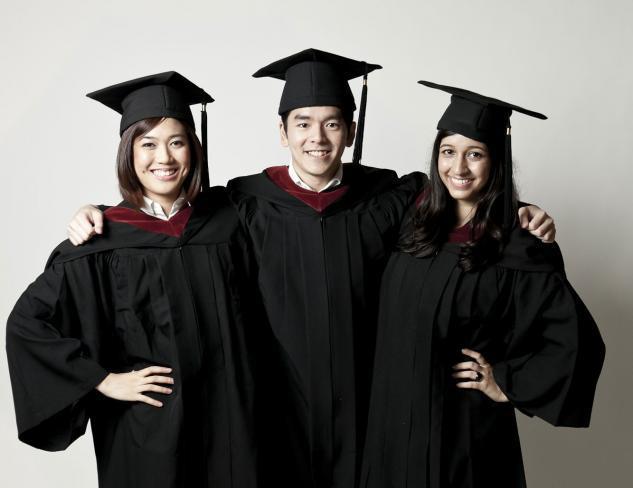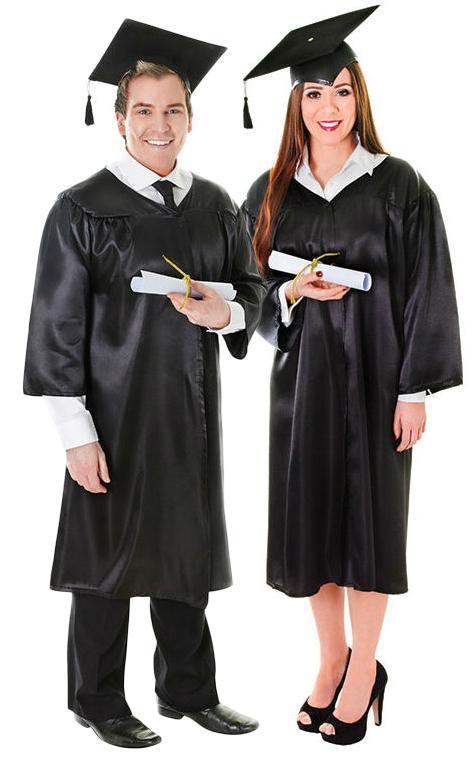The first image is the image on the left, the second image is the image on the right. Given the left and right images, does the statement "There are atleast 5 people total" hold true? Answer yes or no. Yes. The first image is the image on the left, the second image is the image on the right. Assess this claim about the two images: "There are at least five people in total.". Correct or not? Answer yes or no. Yes. 